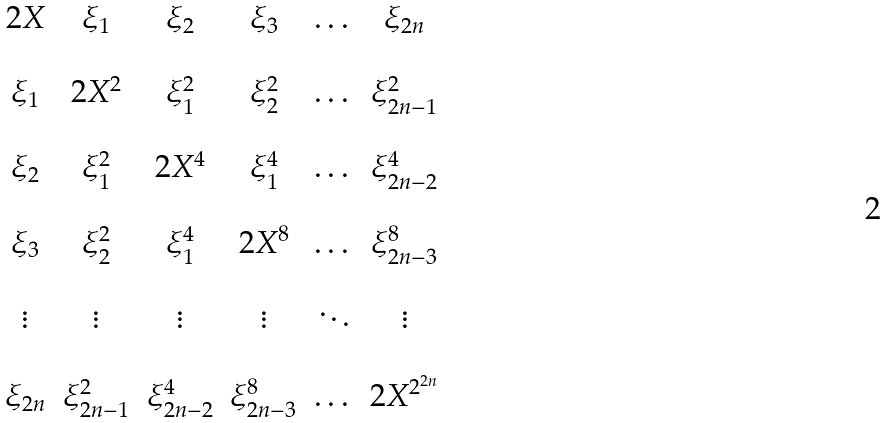Convert formula to latex. <formula><loc_0><loc_0><loc_500><loc_500>\begin{matrix} 2 X & \xi _ { 1 } & \xi _ { 2 } & \xi _ { 3 } & \dots & \xi _ { 2 n } \\ \\ \xi _ { 1 } & 2 X ^ { 2 } & \xi _ { 1 } ^ { 2 } & \xi _ { 2 } ^ { 2 } & \dots & \xi _ { 2 n - 1 } ^ { 2 } \\ \\ \xi _ { 2 } & \xi _ { 1 } ^ { 2 } & 2 X ^ { 4 } & \xi _ { 1 } ^ { 4 } & \dots & \xi _ { 2 n - 2 } ^ { 4 } \\ \\ \xi _ { 3 } & \xi _ { 2 } ^ { 2 } & \xi _ { 1 } ^ { 4 } & 2 X ^ { 8 } & \dots & \xi _ { 2 n - 3 } ^ { 8 } \\ \\ \vdots & \vdots & \vdots & \vdots & \ddots & \vdots \\ \\ \xi _ { 2 n } & \xi _ { 2 n - 1 } ^ { 2 } & \xi _ { 2 n - 2 } ^ { 4 } & \xi _ { 2 n - 3 } ^ { 8 } & \dots & 2 X ^ { 2 ^ { 2 n } } \\ \end{matrix}</formula> 